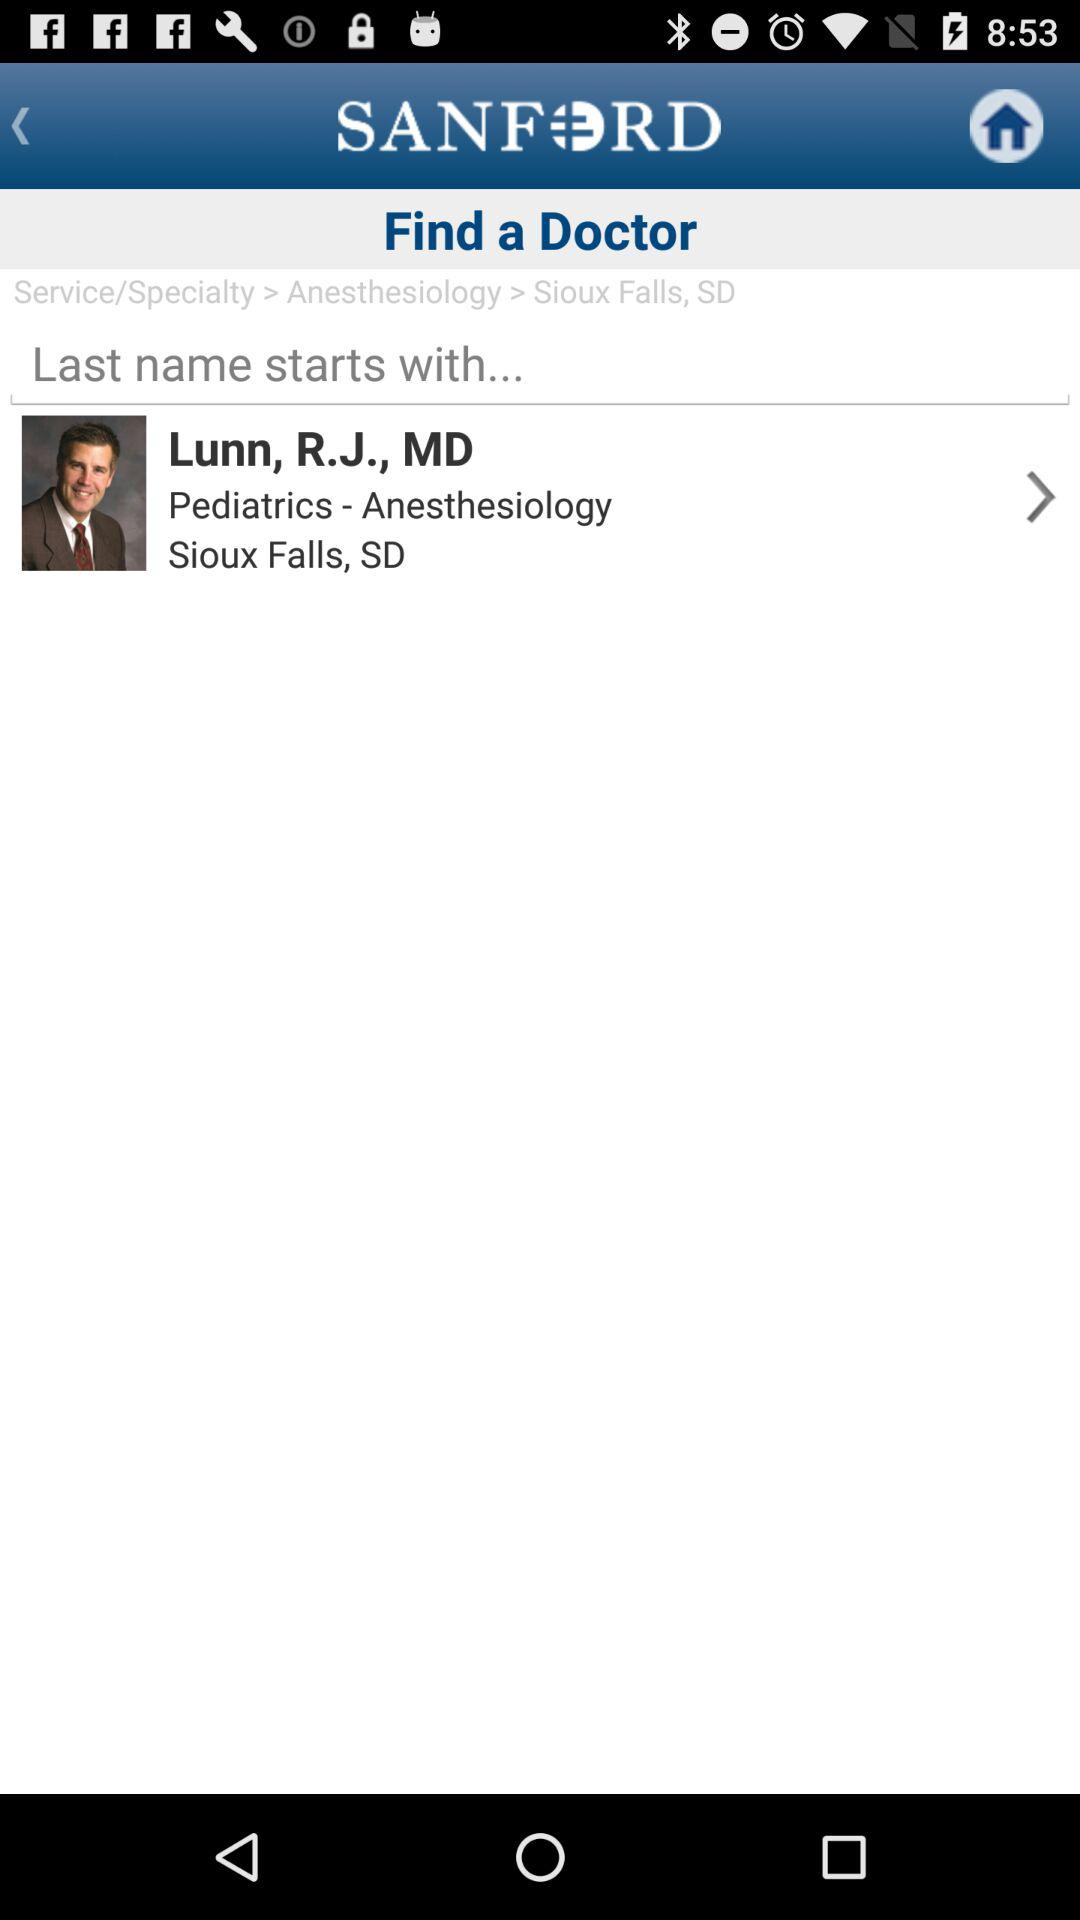What is the name of the mentioned doctor? The name of the mentioned doctor is R.J. Lunn. 